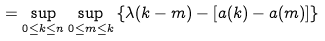<formula> <loc_0><loc_0><loc_500><loc_500>= \sup _ { 0 \leq k \leq n } \sup _ { 0 \leq m \leq k } \left \{ \lambda ( k - m ) - [ a ( k ) - a ( m ) ] \right \}</formula> 